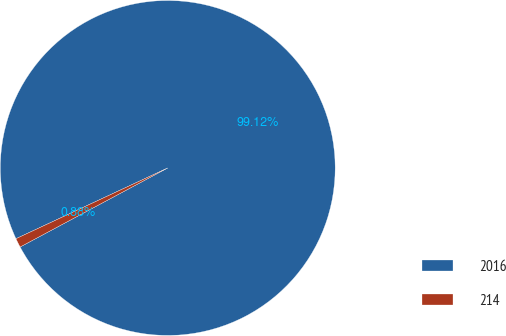Convert chart. <chart><loc_0><loc_0><loc_500><loc_500><pie_chart><fcel>2016<fcel>214<nl><fcel>99.12%<fcel>0.88%<nl></chart> 